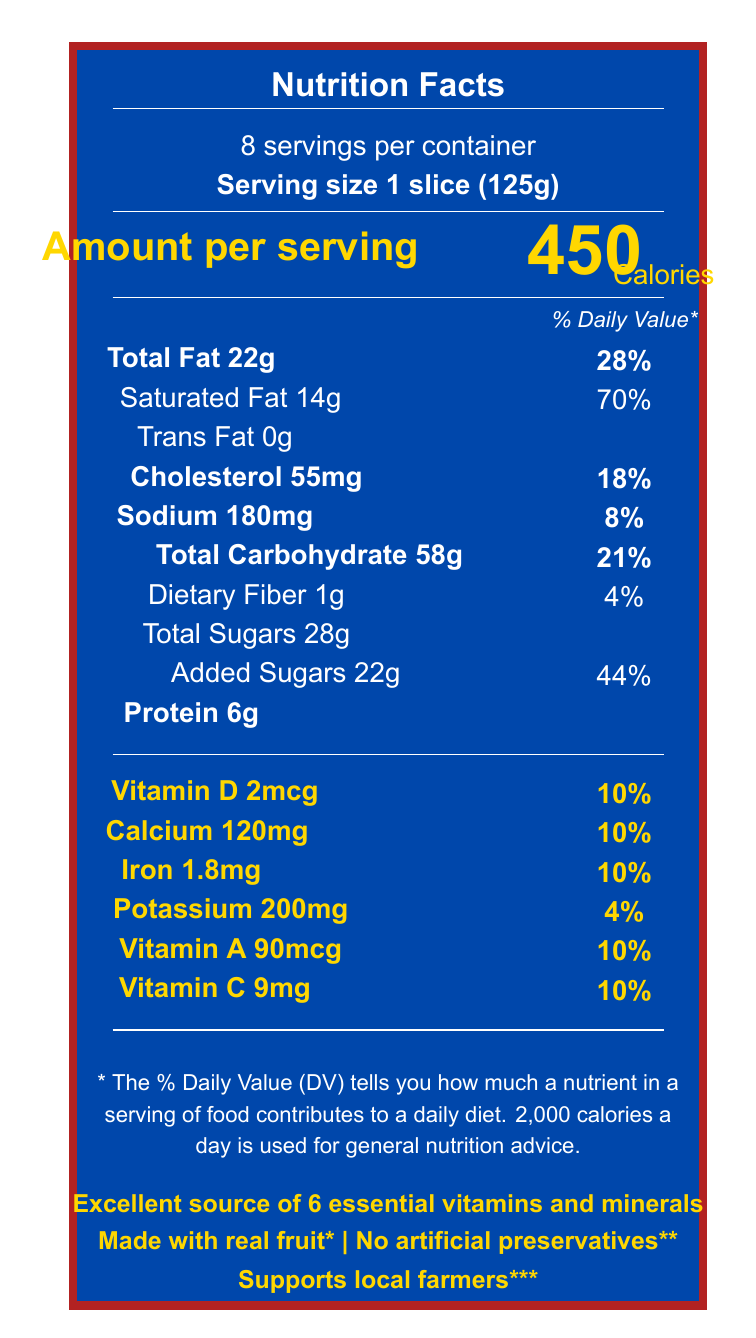what is the serving size per container? The serving size per container is stated as "Serving size 1 slice (125g)" near the beginning of the document.
Answer: 1 slice (125g) how many calories are in one serving of Sweet Freedom Patriot Pie? The document mentions "Amount per serving" and specifies "450" calories per serving.
Answer: 450 what percentage of daily value is saturated fat in one slice? The document indicates that each slice contains 14g of saturated fat, which is 70% of the daily value.
Answer: 70% how much total fat is in one serving, and what is the corresponding daily value percentage? The document states "Total Fat 22g" with a daily value percentage of 28%.
Answer: 22g, 28% does the product contain any trans fat? The section on fats specifies "Trans Fat 0g", which means the product does not contain trans fat.
Answer: No how many vitamins and minerals are highlighted in the document? The document highlights six vitamins and minerals: Vitamin D, Calcium, Iron, Potassium, Vitamin A, and Vitamin C.
Answer: 6 what are the percentages of daily values for vitamin D, calcium, and iron? The document lists each of these nutrients and their respective daily values at 10%.
Answer: 10% for each which of the following statements is found on the document? A. No added sugars B. Good source of protein C. Excellent source of 6 essential vitamins and minerals D. Low sodium The document contains the statement "Excellent source of 6 essential vitamins and minerals."
Answer: C how much added sugar is in one serving, and what is the corresponding daily value percentage? The added sugars section lists "Added Sugars 22g" and provides a daily value percentage of 44%.
Answer: 22g, 44% what is the manufacturer's name and location? The document states "Produced by Patriot Foods Inc., Washington, D.C. 20001."
Answer: Patriot Foods Inc., Washington, D.C. 20001 how many grams of protein are in one serving? A. 4g B. 5g C. 6g D. 7g The document indicates there are 6 grams of protein per serving.
Answer: C does the product contain wheat or soy? The allergen statement specifies "Contains: Wheat, Soy," indicating that the product contains both.
Answer: Yes summarize the main highlights of the document. The summary covers the primary points including serving size, calorie content, highlighted vitamins and minerals, dietary statements, and additional product claims.
Answer: The document provides the nutritional information for Sweet Freedom Patriot Pie, highlighting a serving size of 1 slice (125g) with 450 calories, notable amounts of fat and sugars, and it is an excellent source of 6 essential vitamins and minerals. It also includes statements about supporting local farmers and being made with real fruit. what ingredient is listed as a preservative? In the ingredients list, potassium sorbate is mentioned as a preservative to maintain freshness.
Answer: Potassium Sorbate how is the percentage daily value for total sugars displayed? The document displays the amount of total sugars (28g) but does not provide a percentage daily value.
Answer: Not provided what is the major color scheme of the document? The document is designed using patriot colors with a predominant use of blue and red, reflecting the product's name "Sweet Freedom Patriot Pie".
Answer: Patriot colors, predominantly blue and red does the product support any initiatives? One of the claim statements says "Supports local farmers," and the footnote mentions that a portion of profits supports initiatives for American farmers.
Answer: Yes how much sodium is in one serving and what is the daily value percentage? The document indicates that one serving contains 180mg of sodium which is 8% of the daily value.
Answer: 180mg, 8% what is the exact amount of vitamin C per serving? The vitamins and minerals section lists 9mg of vitamin C per serving.
Answer: 9mg does the claim "no artificial preservatives" apply to the product? Although the document states "No artificial preservatives," a footnote clarifies that it contains potassium sorbate as a preservative.
Answer: No is the daily value percentage for potassium high or low? The document lists the daily value for potassium as 4%, which is considered low.
Answer: Low how much total carbohydrate is in one serving and its daily value percentage? The document indicates 58g of total carbohydrate per serving, which is 21% of the daily value.
Answer: 58g, 21% why might the sugar content be considered obscured in the document? The total sugars amount (28g) is given, but its percentage daily value is not indicated, potentially obscuring the full nutritional impact.
Answer: Because the total sugars percentage daily value is not provided how much dietary fiber is in one serving? The document states there is 1g of dietary fiber per serving, which is 4% of the daily value.
Answer: 1g, 4% 